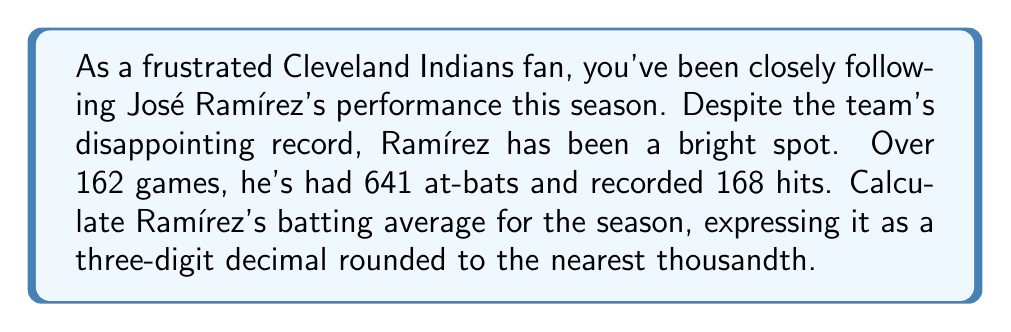What is the answer to this math problem? To calculate a player's batting average, we use the formula:

$$ \text{Batting Average} = \frac{\text{Number of Hits}}{\text{Number of At-Bats}} $$

For José Ramírez:
- Number of Hits = 168
- Number of At-Bats = 641

Let's plug these numbers into the formula:

$$ \text{Batting Average} = \frac{168}{641} $$

Using a calculator or computer, we can perform this division:

$$ \frac{168}{641} \approx 0.2621529485... $$

Rounding to the nearest thousandth (three decimal places), we get:

$$ 0.262 $$

This means José Ramírez's batting average for the season is .262.
Answer: $0.262$ 